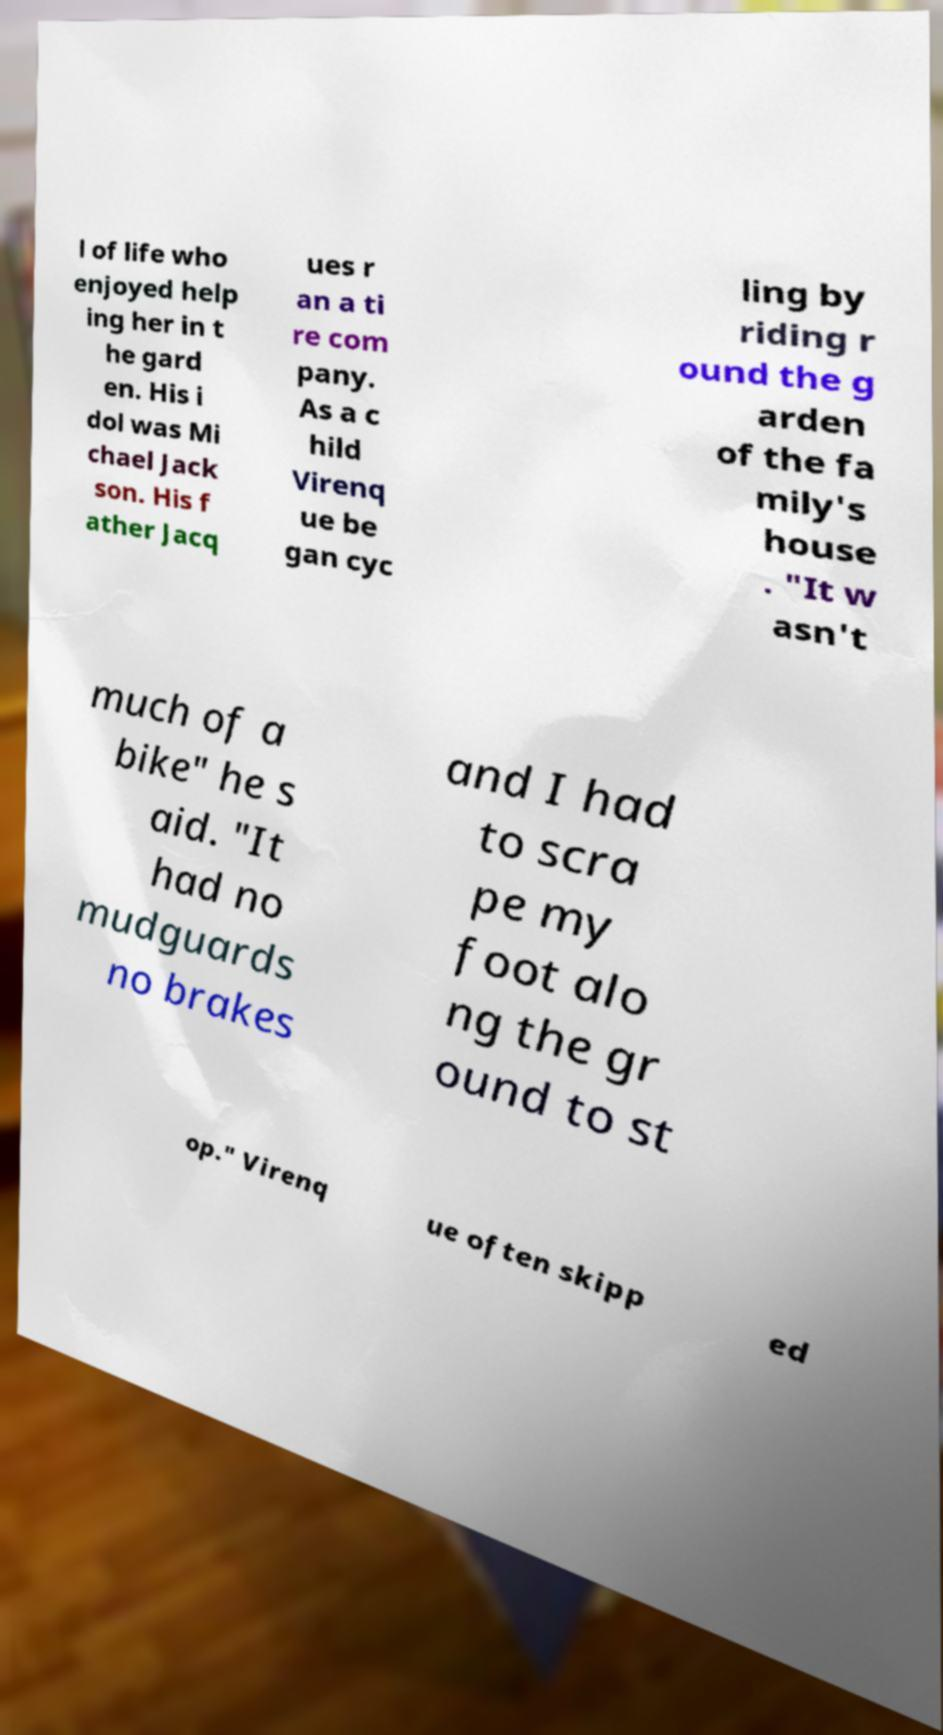Can you read and provide the text displayed in the image?This photo seems to have some interesting text. Can you extract and type it out for me? l of life who enjoyed help ing her in t he gard en. His i dol was Mi chael Jack son. His f ather Jacq ues r an a ti re com pany. As a c hild Virenq ue be gan cyc ling by riding r ound the g arden of the fa mily's house . "It w asn't much of a bike" he s aid. "It had no mudguards no brakes and I had to scra pe my foot alo ng the gr ound to st op." Virenq ue often skipp ed 